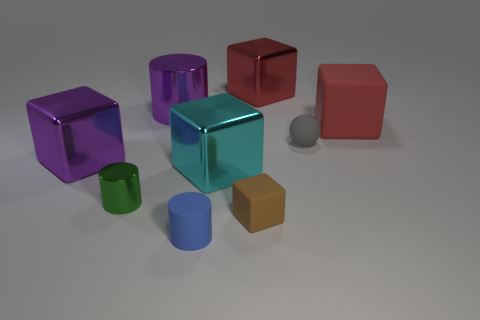Subtract all brown blocks. How many blocks are left? 4 Subtract all red metal blocks. How many blocks are left? 4 Subtract 1 cubes. How many cubes are left? 4 Subtract all yellow blocks. Subtract all cyan spheres. How many blocks are left? 5 Add 1 small cylinders. How many objects exist? 10 Subtract all balls. How many objects are left? 8 Add 6 small metallic cylinders. How many small metallic cylinders are left? 7 Add 5 tiny green shiny cylinders. How many tiny green shiny cylinders exist? 6 Subtract 0 yellow balls. How many objects are left? 9 Subtract all large shiny cubes. Subtract all tiny blue things. How many objects are left? 5 